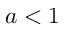<formula> <loc_0><loc_0><loc_500><loc_500>a < 1</formula> 